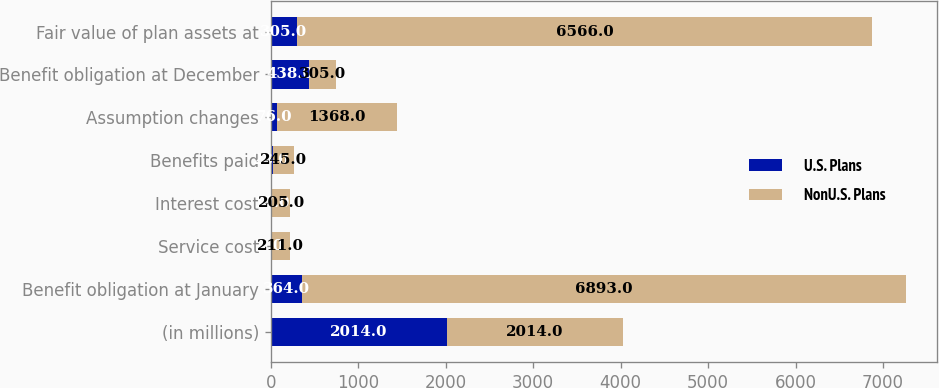Convert chart to OTSL. <chart><loc_0><loc_0><loc_500><loc_500><stacked_bar_chart><ecel><fcel>(in millions)<fcel>Benefit obligation at January<fcel>Service cost<fcel>Interest cost<fcel>Benefits paid<fcel>Assumption changes<fcel>Benefit obligation at December<fcel>Fair value of plan assets at<nl><fcel>U.S. Plans<fcel>2014<fcel>364<fcel>5<fcel>17<fcel>23<fcel>76<fcel>438<fcel>305<nl><fcel>NonU.S. Plans<fcel>2014<fcel>6893<fcel>211<fcel>205<fcel>245<fcel>1368<fcel>305<fcel>6566<nl></chart> 